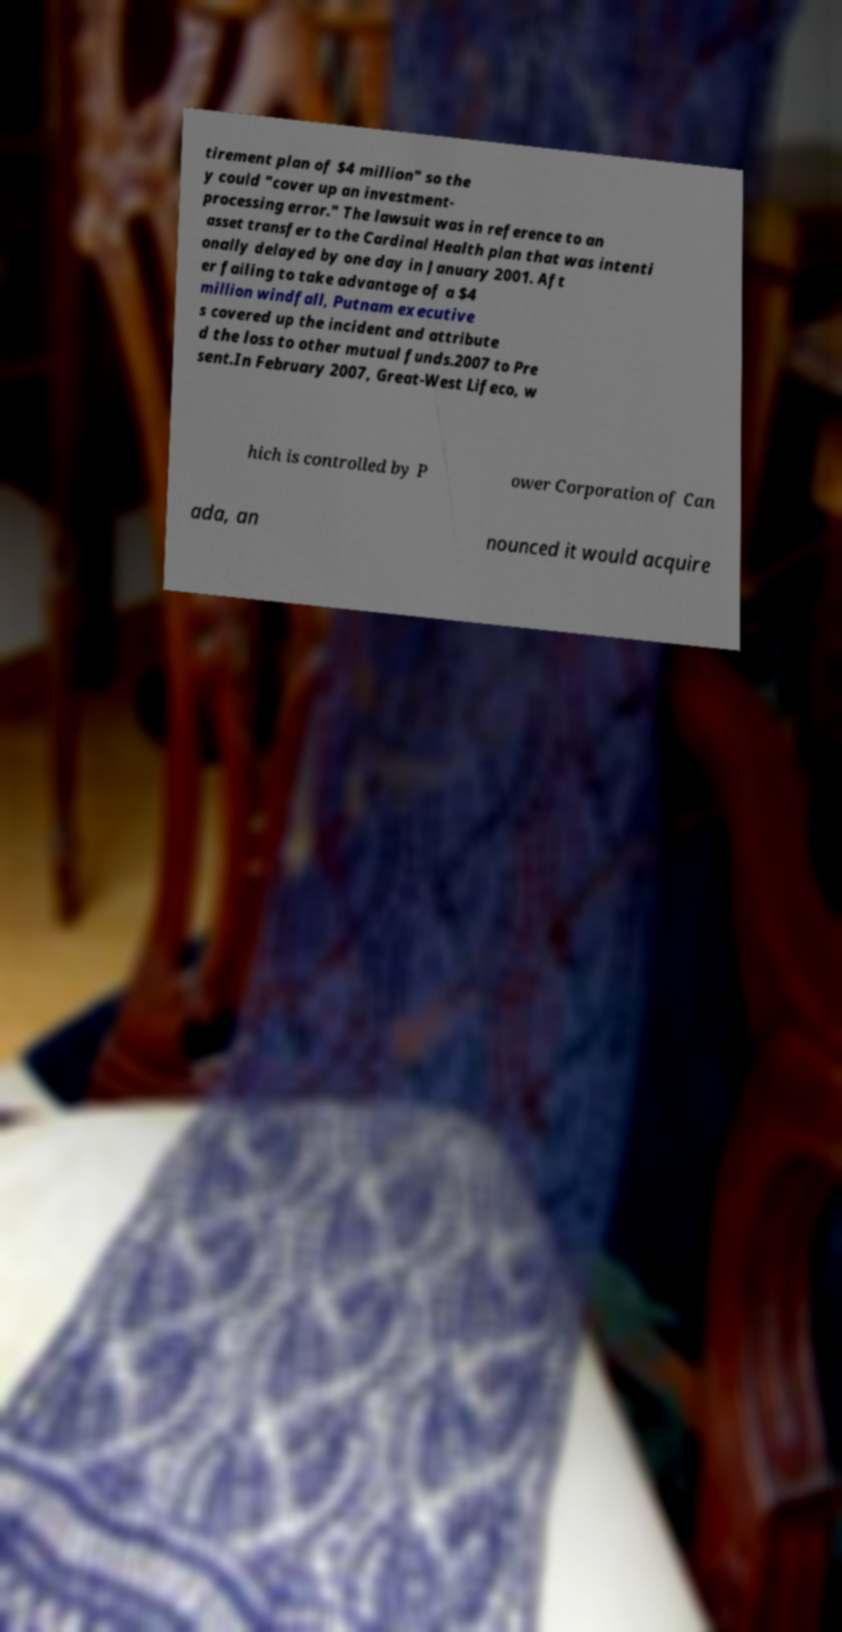For documentation purposes, I need the text within this image transcribed. Could you provide that? tirement plan of $4 million" so the y could "cover up an investment- processing error." The lawsuit was in reference to an asset transfer to the Cardinal Health plan that was intenti onally delayed by one day in January 2001. Aft er failing to take advantage of a $4 million windfall, Putnam executive s covered up the incident and attribute d the loss to other mutual funds.2007 to Pre sent.In February 2007, Great-West Lifeco, w hich is controlled by P ower Corporation of Can ada, an nounced it would acquire 